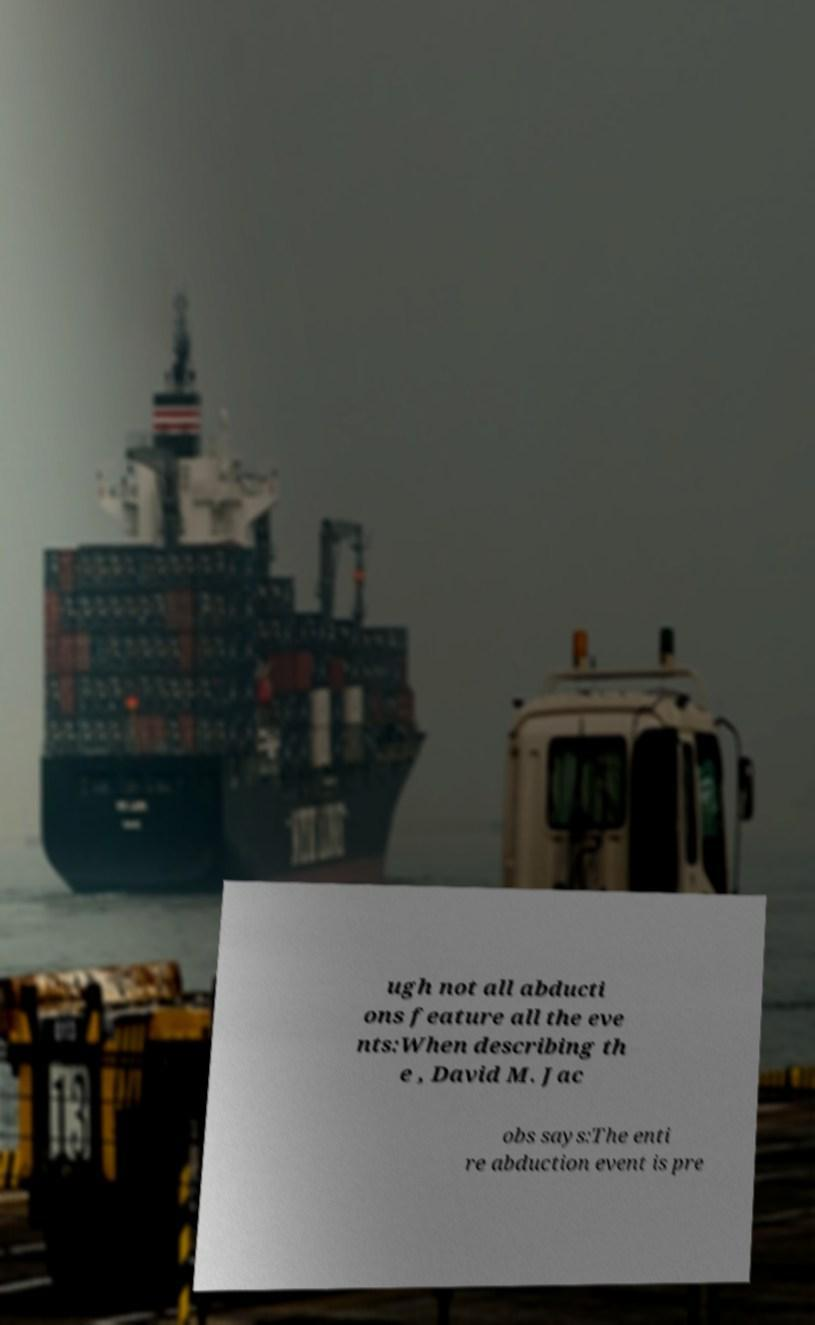Please identify and transcribe the text found in this image. ugh not all abducti ons feature all the eve nts:When describing th e , David M. Jac obs says:The enti re abduction event is pre 